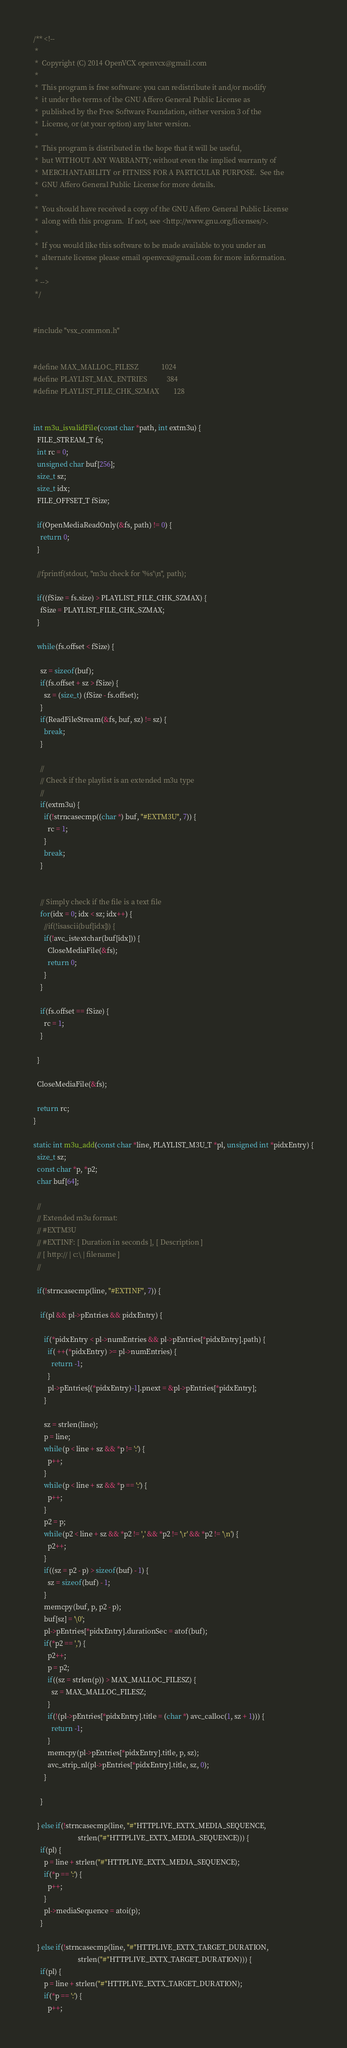<code> <loc_0><loc_0><loc_500><loc_500><_C_>/** <!--
 *
 *  Copyright (C) 2014 OpenVCX openvcx@gmail.com
 *
 *  This program is free software: you can redistribute it and/or modify
 *  it under the terms of the GNU Affero General Public License as
 *  published by the Free Software Foundation, either version 3 of the
 *  License, or (at your option) any later version.
 *
 *  This program is distributed in the hope that it will be useful,
 *  but WITHOUT ANY WARRANTY; without even the implied warranty of
 *  MERCHANTABILITY or FITNESS FOR A PARTICULAR PURPOSE.  See the
 *  GNU Affero General Public License for more details.
 *
 *  You should have received a copy of the GNU Affero General Public License
 *  along with this program.  If not, see <http://www.gnu.org/licenses/>.
 *
 *  If you would like this software to be made available to you under an 
 *  alternate license please email openvcx@gmail.com for more information.
 *
 * -->
 */


#include "vsx_common.h"


#define MAX_MALLOC_FILESZ             1024 
#define PLAYLIST_MAX_ENTRIES           384
#define PLAYLIST_FILE_CHK_SZMAX        128


int m3u_isvalidFile(const char *path, int extm3u) {
  FILE_STREAM_T fs;
  int rc = 0;
  unsigned char buf[256];
  size_t sz;
  size_t idx;
  FILE_OFFSET_T fSize;

  if(OpenMediaReadOnly(&fs, path) != 0) {
    return 0;
  }

  //fprintf(stdout, "m3u check for '%s'\n", path);

  if((fSize = fs.size) > PLAYLIST_FILE_CHK_SZMAX) {
    fSize = PLAYLIST_FILE_CHK_SZMAX;
  }

  while(fs.offset < fSize) {

    sz = sizeof(buf);
    if(fs.offset + sz > fSize) {
      sz = (size_t) (fSize - fs.offset);
    }
    if(ReadFileStream(&fs, buf, sz) != sz) {
      break;
    }

    //
    // Check if the playlist is an extended m3u type
    // 
    if(extm3u) {
      if(!strncasecmp((char *) buf, "#EXTM3U", 7)) {
        rc = 1;
      }
      break;
    }


    // Simply check if the file is a text file
    for(idx = 0; idx < sz; idx++) {
      //if(!isascii(buf[idx])) {
      if(!avc_istextchar(buf[idx])) {
        CloseMediaFile(&fs);
        return 0;
      }
    }

    if(fs.offset == fSize) {
      rc = 1;
    }

  }

  CloseMediaFile(&fs);

  return rc;
}

static int m3u_add(const char *line, PLAYLIST_M3U_T *pl, unsigned int *pidxEntry) {
  size_t sz;
  const char *p, *p2;
  char buf[64];

  //
  // Extended m3u format:
  // #EXTM3U
  // #EXTINF: [ Duration in seconds ], [ Description ]
  // [ http:// | c:\ | filename ]
  //

  if(!strncasecmp(line, "#EXTINF", 7)) {

    if(pl && pl->pEntries && pidxEntry) {

      if(*pidxEntry < pl->numEntries && pl->pEntries[*pidxEntry].path) {
        if( ++(*pidxEntry) >= pl->numEntries) {
          return -1;
        }
        pl->pEntries[(*pidxEntry)-1].pnext = &pl->pEntries[*pidxEntry];
      }

      sz = strlen(line);
      p = line;  
      while(p < line + sz && *p != ':') {
        p++;
      }
      while(p < line + sz && *p == ':') {
        p++;
      }
      p2 = p;
      while(p2 < line + sz && *p2 != ',' && *p2 != '\r' && *p2 != '\n') {
        p2++;
      }
      if((sz = p2 - p) > sizeof(buf) - 1) {
        sz = sizeof(buf) - 1;
      }
      memcpy(buf, p, p2 - p);
      buf[sz] = '\0';
      pl->pEntries[*pidxEntry].durationSec = atof(buf);
      if(*p2 == ',') {
        p2++;
        p = p2;
        if((sz = strlen(p)) > MAX_MALLOC_FILESZ) {
          sz = MAX_MALLOC_FILESZ;
        }
        if(!(pl->pEntries[*pidxEntry].title = (char *) avc_calloc(1, sz + 1))) {
          return -1;
        }
        memcpy(pl->pEntries[*pidxEntry].title, p, sz);
        avc_strip_nl(pl->pEntries[*pidxEntry].title, sz, 0);
      }

    }

  } else if(!strncasecmp(line, "#"HTTPLIVE_EXTX_MEDIA_SEQUENCE, 
                         strlen("#"HTTPLIVE_EXTX_MEDIA_SEQUENCE))) {
    if(pl) {
      p = line + strlen("#"HTTPLIVE_EXTX_MEDIA_SEQUENCE);
      if(*p == ':') {
        p++;
      }
      pl->mediaSequence = atoi(p);
    }

  } else if(!strncasecmp(line, "#"HTTPLIVE_EXTX_TARGET_DURATION, 
                         strlen("#"HTTPLIVE_EXTX_TARGET_DURATION))) {
    if(pl) {
      p = line + strlen("#"HTTPLIVE_EXTX_TARGET_DURATION);
      if(*p == ':') {
        p++;</code> 